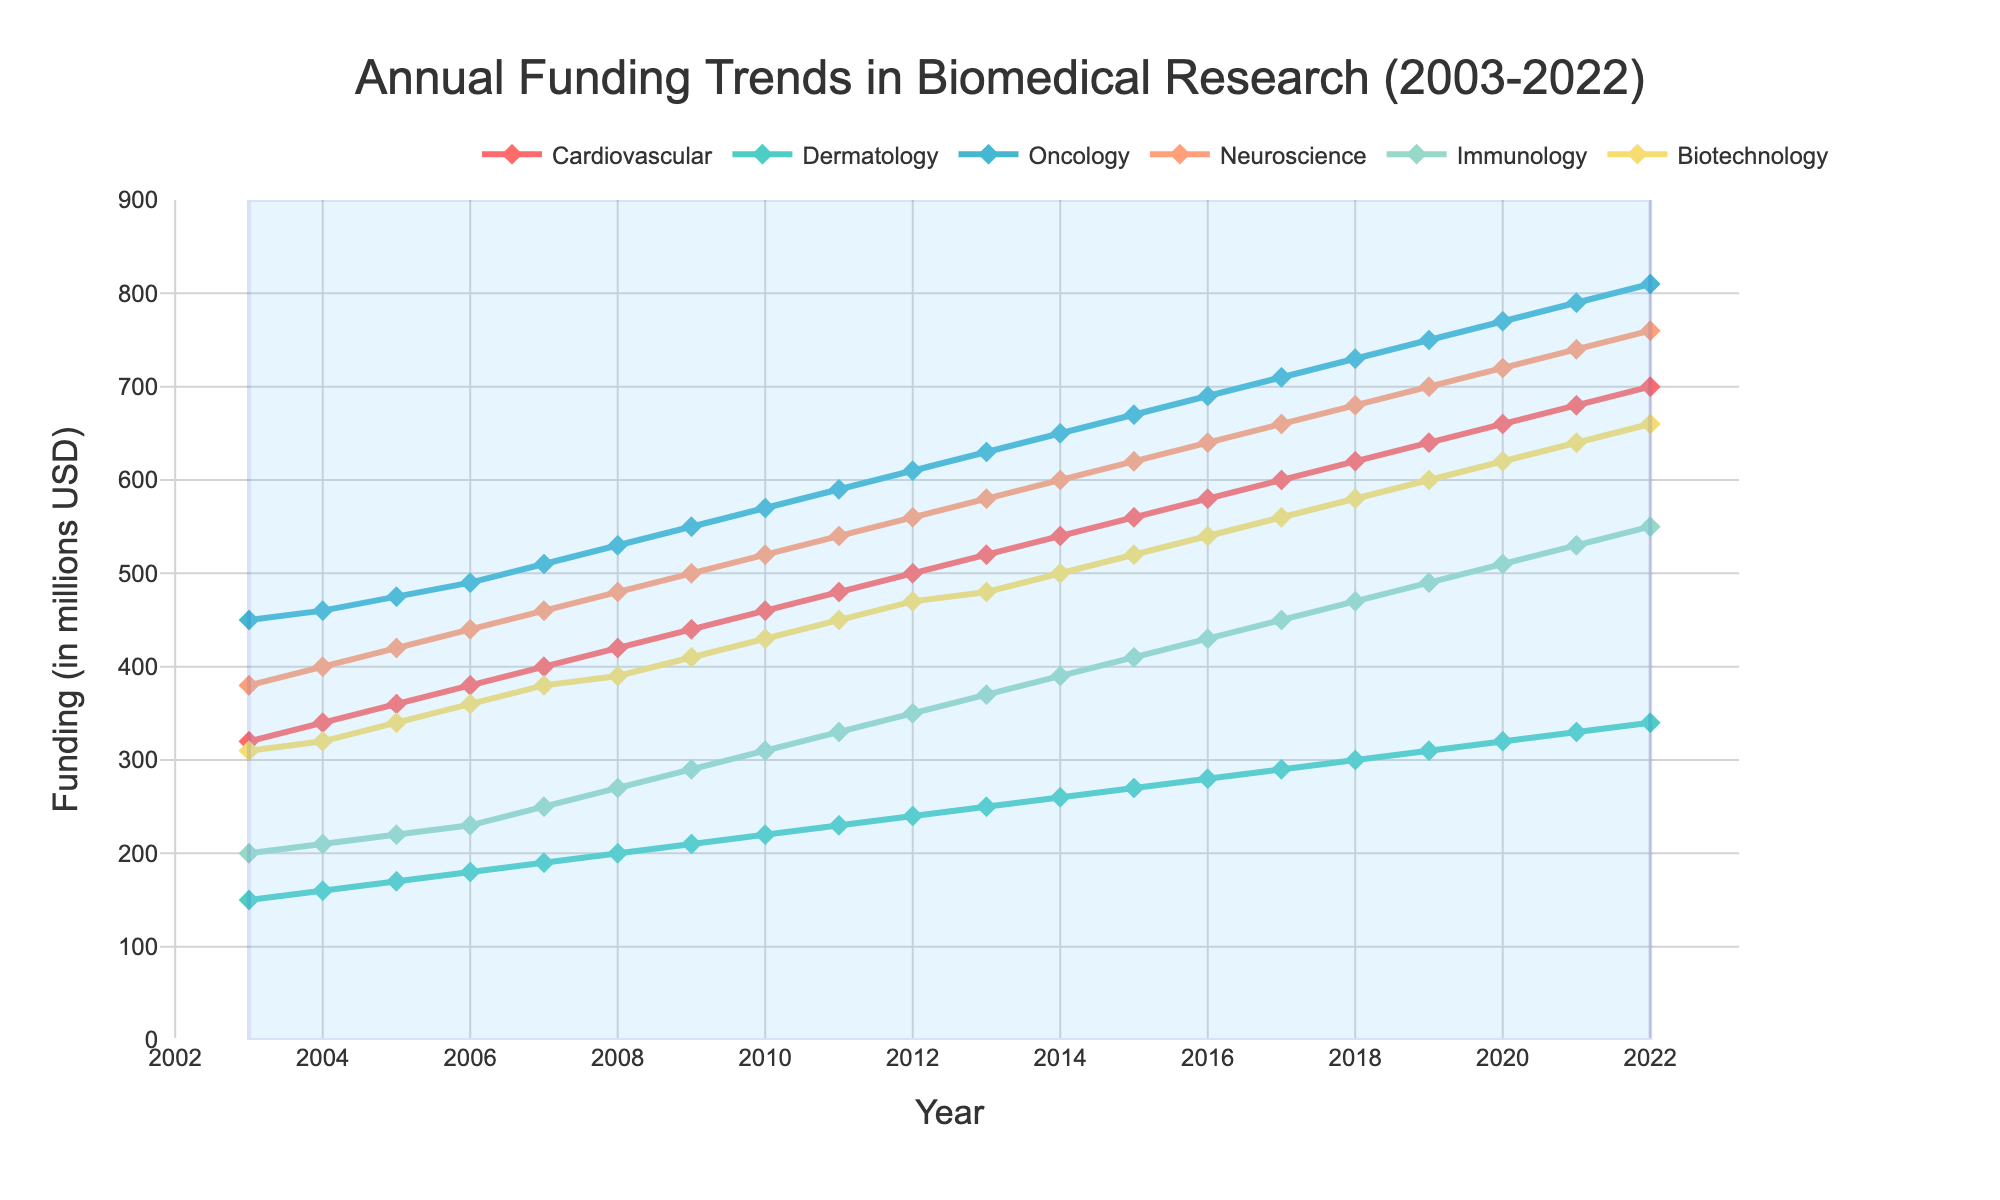What is the title of the figure? The title is usually located at the top center of the figure. It provides a concise summary of what the figure represents.
Answer: Annual Funding Trends in Biomedical Research (2003-2022) What is the X-axis label? The X-axis label is located at the bottom of the figure and indicates what the data points on the horizontal axis represent.
Answer: Year What is the Y-axis label? The Y-axis label is located at the left side of the figure and indicates what the data points on the vertical axis represent.
Answer: Funding (in millions USD) Which research area received the highest amount of funding in 2022? To determine this, look at the data points for each research area at the year 2022 on the X-axis and see which has the highest value on the Y-axis.
Answer: Oncology Which research area received the lowest amount of funding in 2003? Check the data points for each research area at the year 2003 on the X-axis and see which has the lowest value on the Y-axis.
Answer: Dermatology How much funding did Immunology receive in 2015? Locate the year 2015 on the X-axis, then find the corresponding data point for Immunology on the Y-axis.
Answer: 410 million USD What is the trend of funding for Neuroscience from 2003 to 2022? Observe the data points for Neuroscience from 2003 to 2022. Note whether the funding is increasing, decreasing, or staying constant over the years.
Answer: Increasing Which research area had a funding increase of 100 million USD between 2013 and 2018? Calculate the difference in funding for each research area between 2013 and 2018 and check which difference equals 100 million USD.
Answer: Dermatology Which research area exhibited the most consistent growth in funding over the entire period? Consistent growth implies a steady, almost linear increase over time. Check which research area has such a trend by observing their data points from 2003 to 2022.
Answer: Biotechnology What was the average funding for Cardiovascular research from 2010 to 2020? Calculate the total funding for Cardiovascular from 2010 to 2020, then divide by the number of years (11).
Answer: (460 + 480 + 500 + 520 + 540 + 560 + 580 + 600 + 620 + 640 + 660) / 11 = 35.45 How does the total funding across all research areas compare between 2003 and 2022? Sum the funding amounts for all the research areas in 2003 and 2022, then compare the two totals.
Answer: 1810 million USD in 2003 and 3920 million USD in 2022 